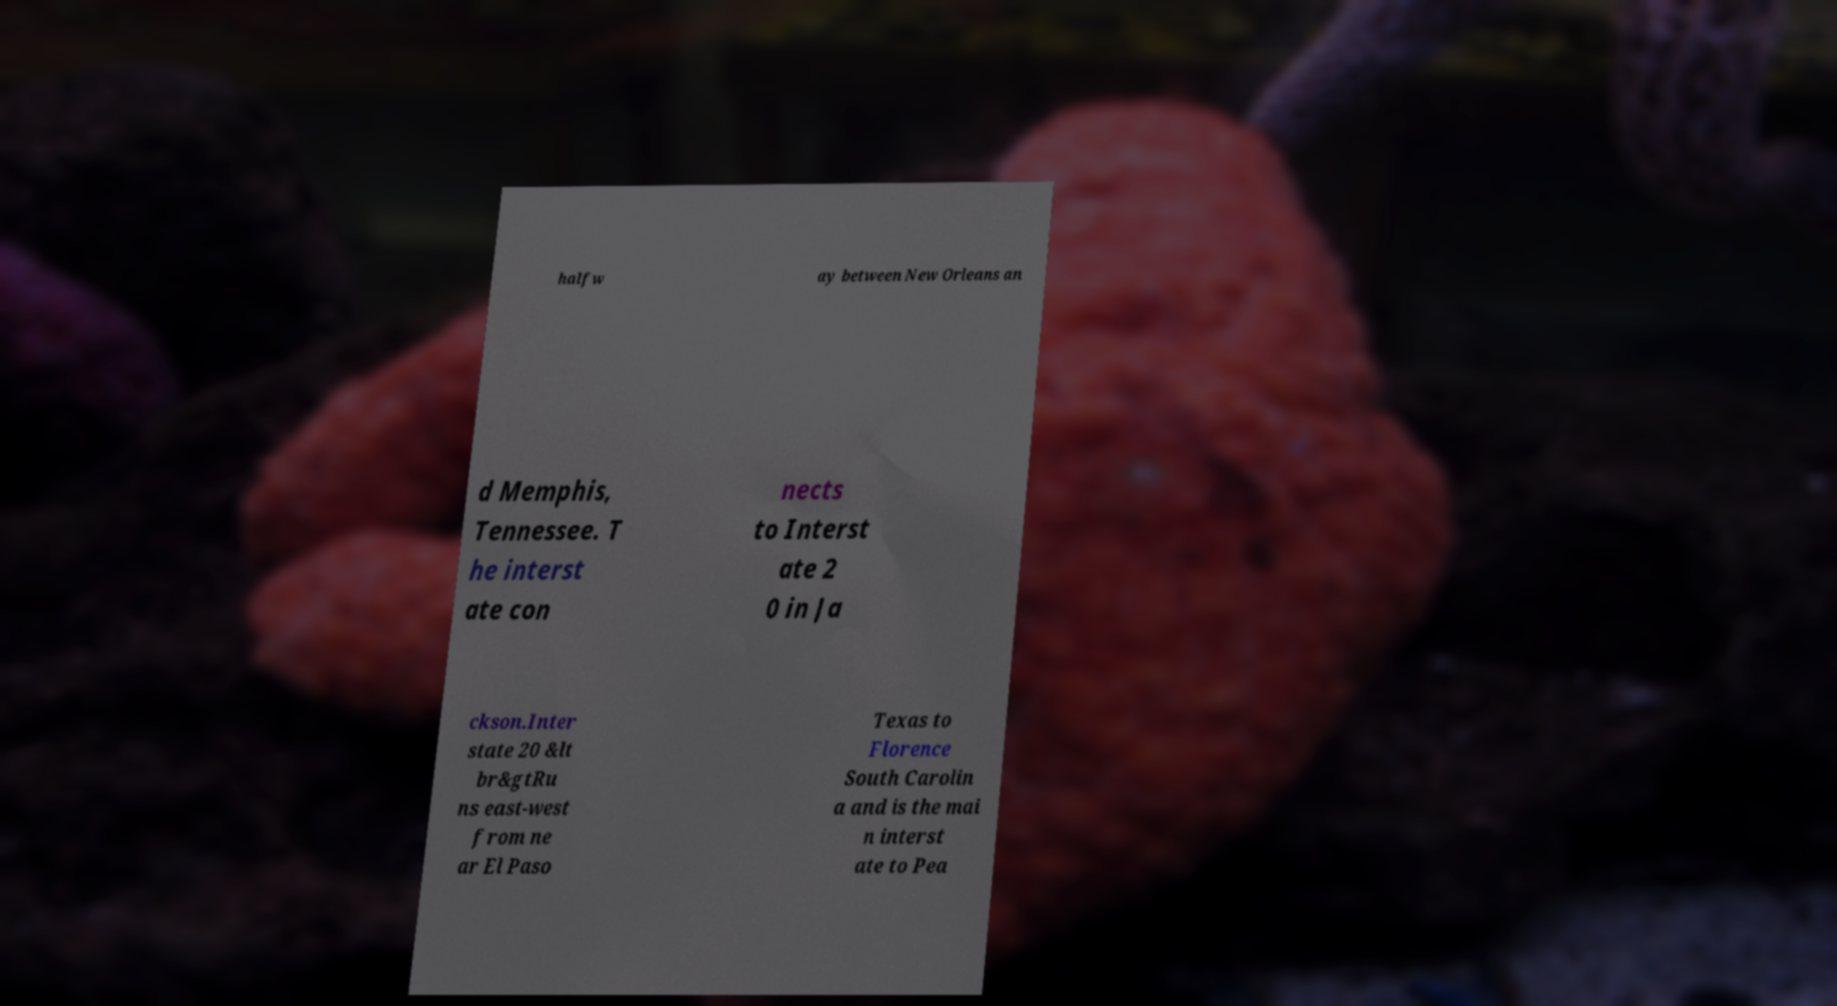Can you read and provide the text displayed in the image?This photo seems to have some interesting text. Can you extract and type it out for me? halfw ay between New Orleans an d Memphis, Tennessee. T he interst ate con nects to Interst ate 2 0 in Ja ckson.Inter state 20 &lt br&gtRu ns east-west from ne ar El Paso Texas to Florence South Carolin a and is the mai n interst ate to Pea 